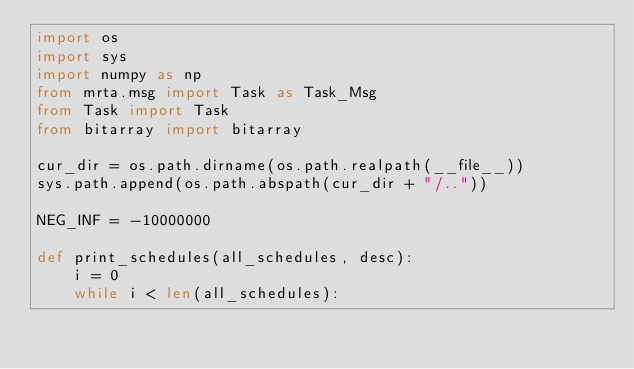<code> <loc_0><loc_0><loc_500><loc_500><_Python_>import os
import sys
import numpy as np
from mrta.msg import Task as Task_Msg
from Task import Task
from bitarray import bitarray

cur_dir = os.path.dirname(os.path.realpath(__file__))
sys.path.append(os.path.abspath(cur_dir + "/.."))

NEG_INF = -10000000

def print_schedules(all_schedules, desc):    
    i = 0
    while i < len(all_schedules):             </code> 